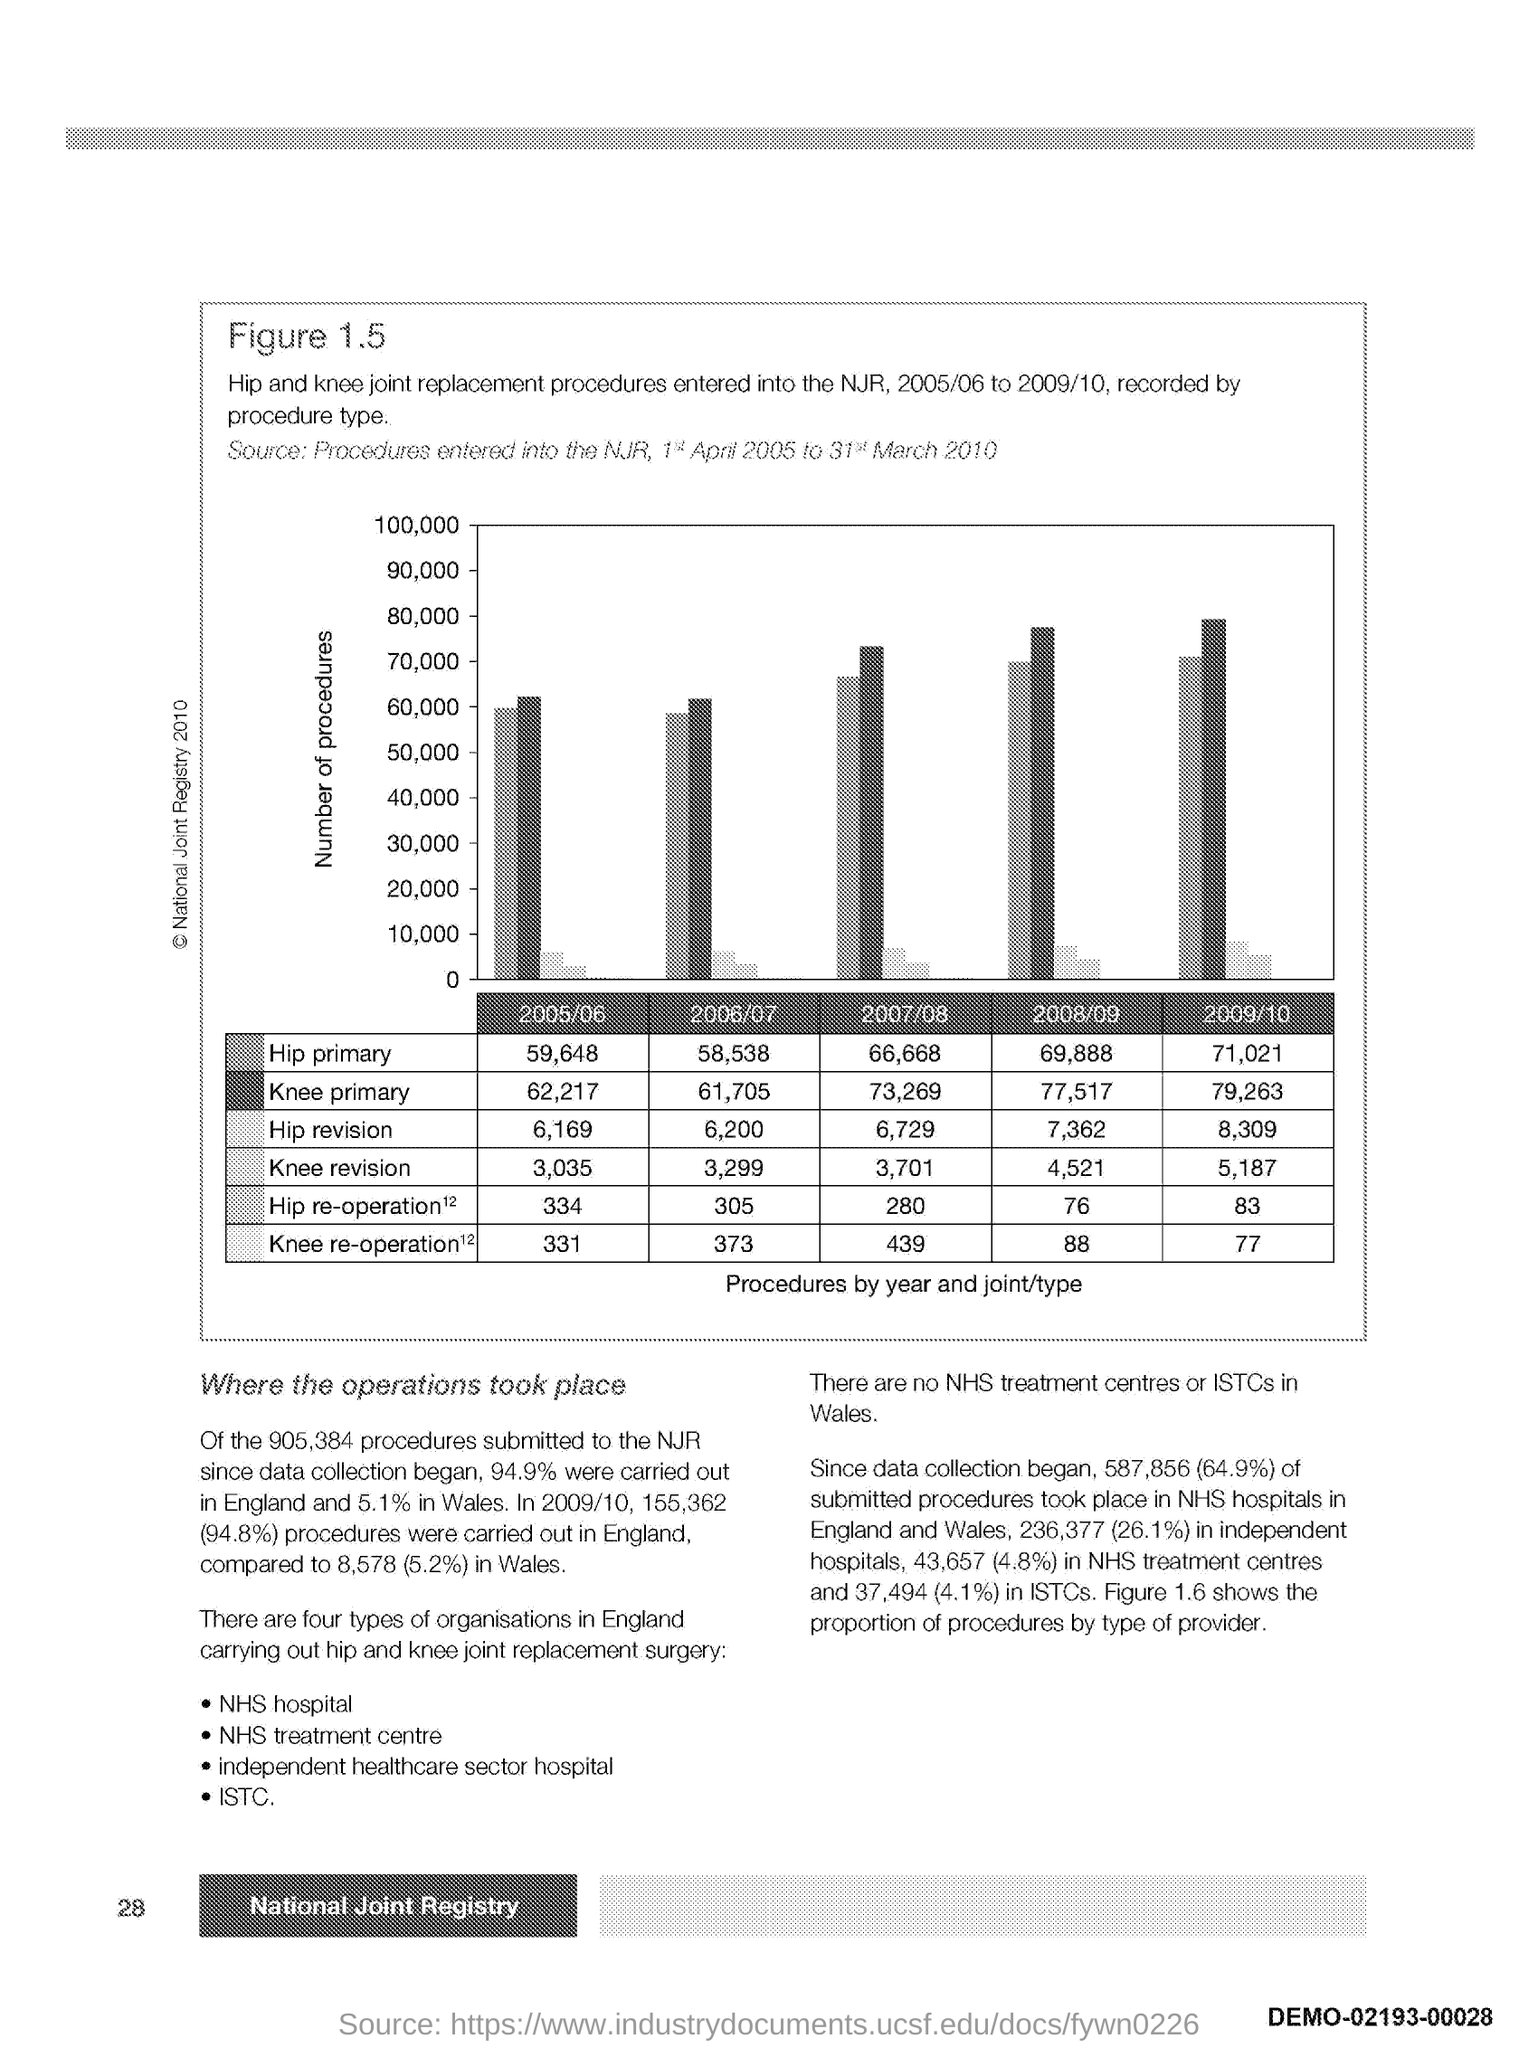How many Hip primary procedure were done in 2005/06?
Keep it short and to the point. 59,648. How many Hip primary procedure were done in 2006/07?
Your answer should be compact. 58,538. How many Hip primary procedure were done in 2007/08?
Provide a succinct answer. 66,668. How many Hip primary procedure were done in 2008/09?
Provide a succinct answer. 69,888. How many Hip primary procedure were done in 2009/10?
Give a very brief answer. 71,021. How many Knee primary procedure were done in 2005/06?
Make the answer very short. 62,217. How many Knee primary procedure were done in 2006/07?
Offer a very short reply. 61,705. 